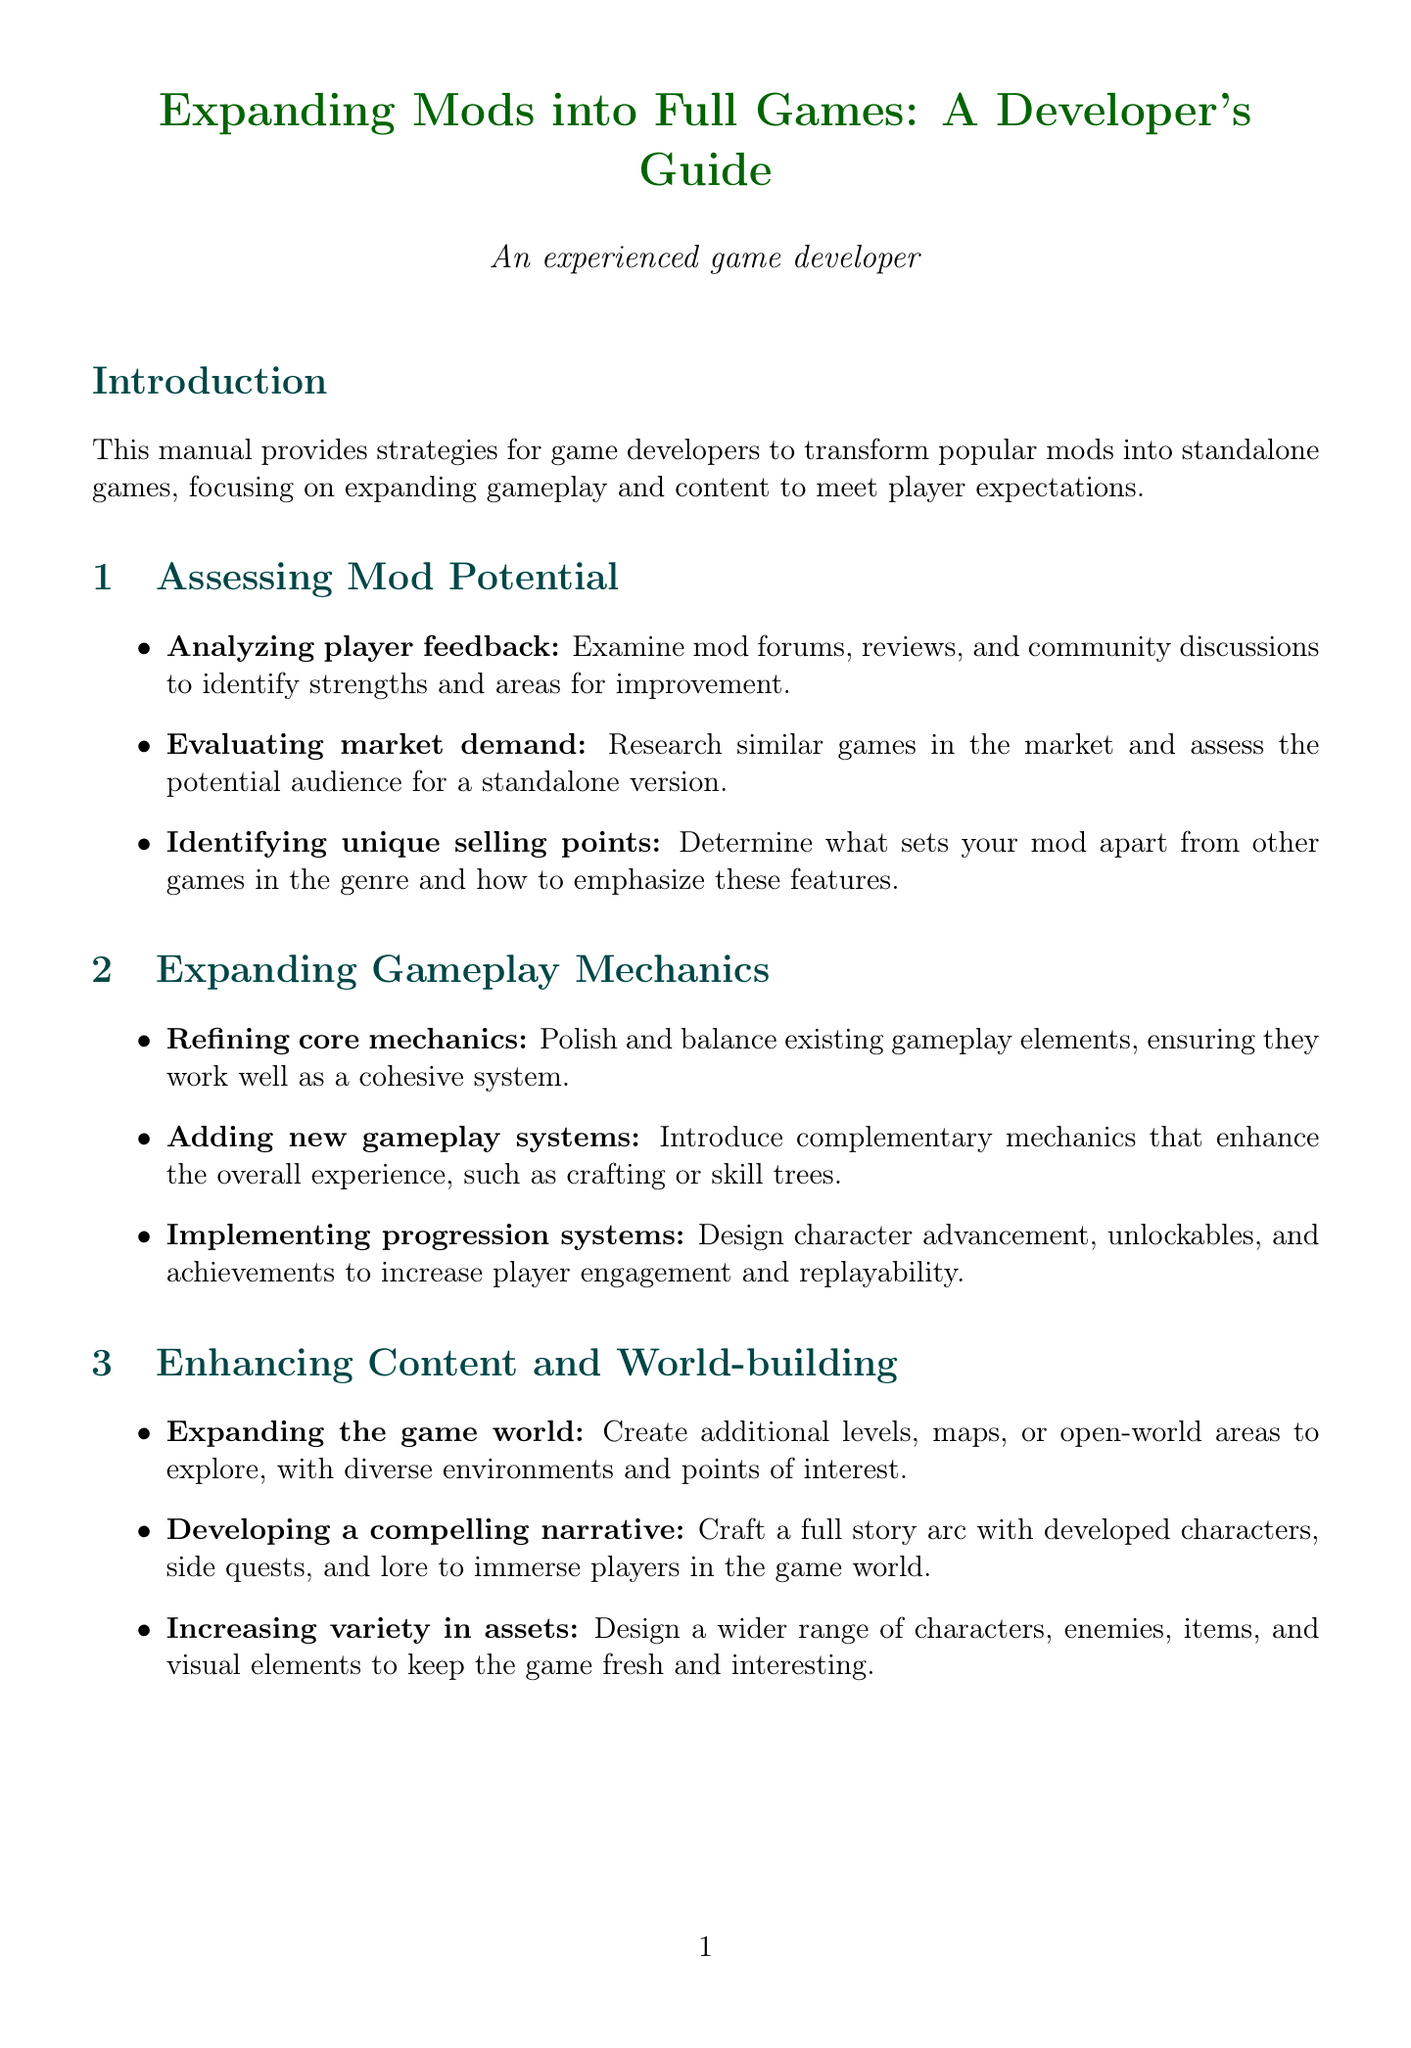What is the title of the manual? The title of the manual is stated in the introduction section.
Answer: Expanding Mods into Full Games: A Developer's Guide What is one way to assess mod potential? The document lists several strategies for assessing mod potential.
Answer: Analyzing player feedback What does the section on expanding the game world suggest? The document describes how to enhance content and world-building.
Answer: Create additional levels, maps, or open-world areas How many case studies are mentioned? The section on case studies shows the number of examples provided.
Answer: Three What is a component of optimizing performance? The technical considerations chapter lists ways to improve game performance.
Answer: Improve frame rates What is an example of a game that evolved from a mod? The case studies section provides examples of mods that became standalone games.
Answer: DOTA 2 Name one strategy for community management mentioned in the manual. The marketing and community management chapter identifies key strategies for player engagement.
Answer: Engaging with the community What type of content does the manual recommend localizing? User interface and experience section addresses various aspects of game content.
Answer: Text and audio 